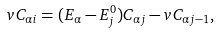Convert formula to latex. <formula><loc_0><loc_0><loc_500><loc_500>v C _ { \alpha i } = ( E _ { \alpha } - E ^ { 0 } _ { j } ) C _ { \alpha j } - v C _ { \alpha j - 1 } ,</formula> 